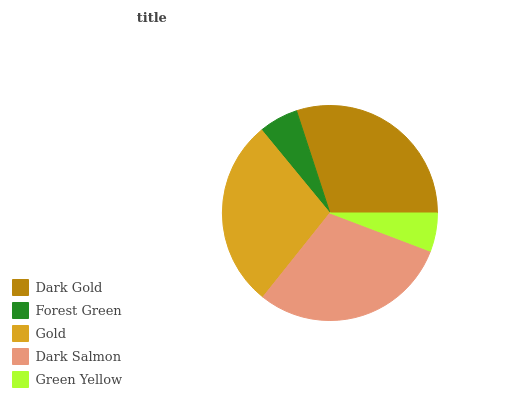Is Green Yellow the minimum?
Answer yes or no. Yes. Is Dark Gold the maximum?
Answer yes or no. Yes. Is Forest Green the minimum?
Answer yes or no. No. Is Forest Green the maximum?
Answer yes or no. No. Is Dark Gold greater than Forest Green?
Answer yes or no. Yes. Is Forest Green less than Dark Gold?
Answer yes or no. Yes. Is Forest Green greater than Dark Gold?
Answer yes or no. No. Is Dark Gold less than Forest Green?
Answer yes or no. No. Is Gold the high median?
Answer yes or no. Yes. Is Gold the low median?
Answer yes or no. Yes. Is Green Yellow the high median?
Answer yes or no. No. Is Forest Green the low median?
Answer yes or no. No. 